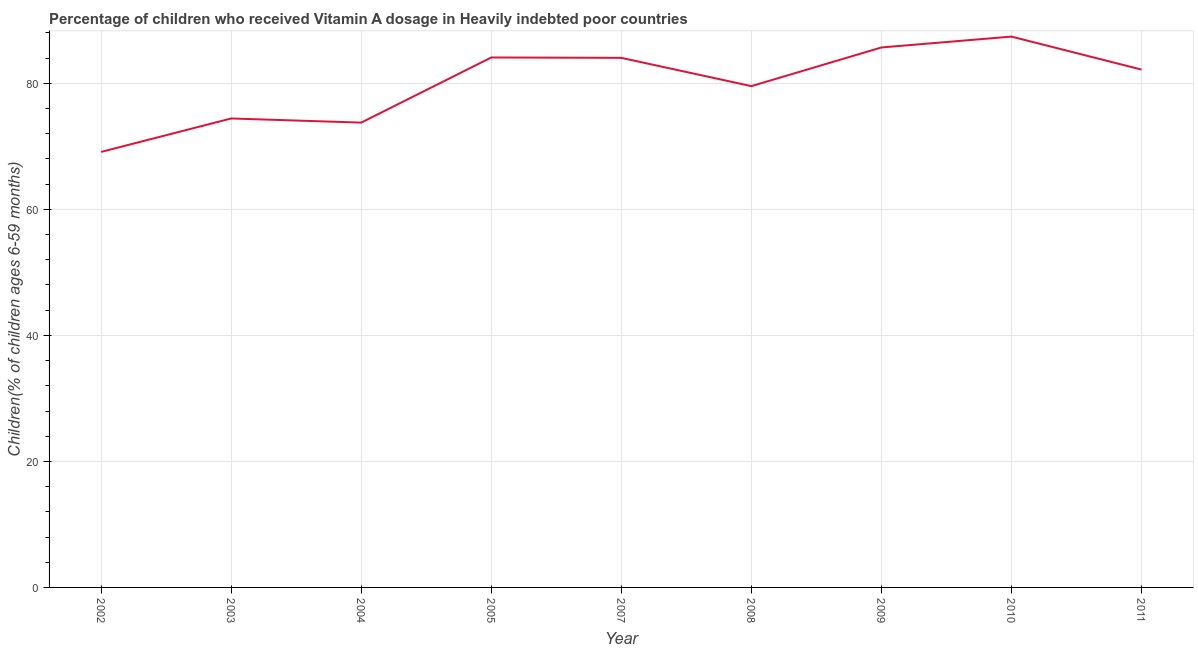What is the vitamin a supplementation coverage rate in 2009?
Make the answer very short. 85.7. Across all years, what is the maximum vitamin a supplementation coverage rate?
Your answer should be compact. 87.42. Across all years, what is the minimum vitamin a supplementation coverage rate?
Make the answer very short. 69.12. In which year was the vitamin a supplementation coverage rate minimum?
Offer a terse response. 2002. What is the sum of the vitamin a supplementation coverage rate?
Give a very brief answer. 720.35. What is the difference between the vitamin a supplementation coverage rate in 2002 and 2003?
Make the answer very short. -5.3. What is the average vitamin a supplementation coverage rate per year?
Provide a succinct answer. 80.04. What is the median vitamin a supplementation coverage rate?
Make the answer very short. 82.19. What is the ratio of the vitamin a supplementation coverage rate in 2007 to that in 2008?
Offer a terse response. 1.06. Is the vitamin a supplementation coverage rate in 2009 less than that in 2010?
Your response must be concise. Yes. What is the difference between the highest and the second highest vitamin a supplementation coverage rate?
Give a very brief answer. 1.72. What is the difference between the highest and the lowest vitamin a supplementation coverage rate?
Provide a succinct answer. 18.3. In how many years, is the vitamin a supplementation coverage rate greater than the average vitamin a supplementation coverage rate taken over all years?
Your answer should be compact. 5. Does the vitamin a supplementation coverage rate monotonically increase over the years?
Keep it short and to the point. No. How many lines are there?
Your answer should be very brief. 1. How many years are there in the graph?
Your answer should be very brief. 9. Are the values on the major ticks of Y-axis written in scientific E-notation?
Provide a succinct answer. No. Does the graph contain any zero values?
Offer a terse response. No. What is the title of the graph?
Provide a succinct answer. Percentage of children who received Vitamin A dosage in Heavily indebted poor countries. What is the label or title of the Y-axis?
Your answer should be very brief. Children(% of children ages 6-59 months). What is the Children(% of children ages 6-59 months) in 2002?
Provide a succinct answer. 69.12. What is the Children(% of children ages 6-59 months) in 2003?
Provide a short and direct response. 74.43. What is the Children(% of children ages 6-59 months) in 2004?
Make the answer very short. 73.77. What is the Children(% of children ages 6-59 months) in 2005?
Give a very brief answer. 84.11. What is the Children(% of children ages 6-59 months) in 2007?
Give a very brief answer. 84.05. What is the Children(% of children ages 6-59 months) in 2008?
Give a very brief answer. 79.56. What is the Children(% of children ages 6-59 months) in 2009?
Ensure brevity in your answer.  85.7. What is the Children(% of children ages 6-59 months) of 2010?
Your answer should be compact. 87.42. What is the Children(% of children ages 6-59 months) in 2011?
Ensure brevity in your answer.  82.19. What is the difference between the Children(% of children ages 6-59 months) in 2002 and 2003?
Your answer should be compact. -5.3. What is the difference between the Children(% of children ages 6-59 months) in 2002 and 2004?
Offer a very short reply. -4.65. What is the difference between the Children(% of children ages 6-59 months) in 2002 and 2005?
Make the answer very short. -14.99. What is the difference between the Children(% of children ages 6-59 months) in 2002 and 2007?
Provide a short and direct response. -14.93. What is the difference between the Children(% of children ages 6-59 months) in 2002 and 2008?
Make the answer very short. -10.44. What is the difference between the Children(% of children ages 6-59 months) in 2002 and 2009?
Your answer should be very brief. -16.58. What is the difference between the Children(% of children ages 6-59 months) in 2002 and 2010?
Ensure brevity in your answer.  -18.3. What is the difference between the Children(% of children ages 6-59 months) in 2002 and 2011?
Make the answer very short. -13.07. What is the difference between the Children(% of children ages 6-59 months) in 2003 and 2004?
Your answer should be compact. 0.66. What is the difference between the Children(% of children ages 6-59 months) in 2003 and 2005?
Make the answer very short. -9.68. What is the difference between the Children(% of children ages 6-59 months) in 2003 and 2007?
Make the answer very short. -9.62. What is the difference between the Children(% of children ages 6-59 months) in 2003 and 2008?
Provide a short and direct response. -5.13. What is the difference between the Children(% of children ages 6-59 months) in 2003 and 2009?
Offer a terse response. -11.27. What is the difference between the Children(% of children ages 6-59 months) in 2003 and 2010?
Ensure brevity in your answer.  -13. What is the difference between the Children(% of children ages 6-59 months) in 2003 and 2011?
Make the answer very short. -7.76. What is the difference between the Children(% of children ages 6-59 months) in 2004 and 2005?
Offer a terse response. -10.34. What is the difference between the Children(% of children ages 6-59 months) in 2004 and 2007?
Provide a succinct answer. -10.28. What is the difference between the Children(% of children ages 6-59 months) in 2004 and 2008?
Give a very brief answer. -5.79. What is the difference between the Children(% of children ages 6-59 months) in 2004 and 2009?
Keep it short and to the point. -11.93. What is the difference between the Children(% of children ages 6-59 months) in 2004 and 2010?
Your answer should be very brief. -13.65. What is the difference between the Children(% of children ages 6-59 months) in 2004 and 2011?
Your answer should be very brief. -8.42. What is the difference between the Children(% of children ages 6-59 months) in 2005 and 2007?
Keep it short and to the point. 0.06. What is the difference between the Children(% of children ages 6-59 months) in 2005 and 2008?
Give a very brief answer. 4.55. What is the difference between the Children(% of children ages 6-59 months) in 2005 and 2009?
Give a very brief answer. -1.59. What is the difference between the Children(% of children ages 6-59 months) in 2005 and 2010?
Give a very brief answer. -3.31. What is the difference between the Children(% of children ages 6-59 months) in 2005 and 2011?
Ensure brevity in your answer.  1.92. What is the difference between the Children(% of children ages 6-59 months) in 2007 and 2008?
Your response must be concise. 4.49. What is the difference between the Children(% of children ages 6-59 months) in 2007 and 2009?
Give a very brief answer. -1.65. What is the difference between the Children(% of children ages 6-59 months) in 2007 and 2010?
Give a very brief answer. -3.37. What is the difference between the Children(% of children ages 6-59 months) in 2007 and 2011?
Ensure brevity in your answer.  1.86. What is the difference between the Children(% of children ages 6-59 months) in 2008 and 2009?
Offer a terse response. -6.14. What is the difference between the Children(% of children ages 6-59 months) in 2008 and 2010?
Offer a very short reply. -7.86. What is the difference between the Children(% of children ages 6-59 months) in 2008 and 2011?
Keep it short and to the point. -2.63. What is the difference between the Children(% of children ages 6-59 months) in 2009 and 2010?
Your response must be concise. -1.72. What is the difference between the Children(% of children ages 6-59 months) in 2009 and 2011?
Your answer should be compact. 3.51. What is the difference between the Children(% of children ages 6-59 months) in 2010 and 2011?
Your response must be concise. 5.23. What is the ratio of the Children(% of children ages 6-59 months) in 2002 to that in 2003?
Keep it short and to the point. 0.93. What is the ratio of the Children(% of children ages 6-59 months) in 2002 to that in 2004?
Provide a succinct answer. 0.94. What is the ratio of the Children(% of children ages 6-59 months) in 2002 to that in 2005?
Keep it short and to the point. 0.82. What is the ratio of the Children(% of children ages 6-59 months) in 2002 to that in 2007?
Provide a succinct answer. 0.82. What is the ratio of the Children(% of children ages 6-59 months) in 2002 to that in 2008?
Provide a succinct answer. 0.87. What is the ratio of the Children(% of children ages 6-59 months) in 2002 to that in 2009?
Ensure brevity in your answer.  0.81. What is the ratio of the Children(% of children ages 6-59 months) in 2002 to that in 2010?
Ensure brevity in your answer.  0.79. What is the ratio of the Children(% of children ages 6-59 months) in 2002 to that in 2011?
Keep it short and to the point. 0.84. What is the ratio of the Children(% of children ages 6-59 months) in 2003 to that in 2004?
Make the answer very short. 1.01. What is the ratio of the Children(% of children ages 6-59 months) in 2003 to that in 2005?
Give a very brief answer. 0.89. What is the ratio of the Children(% of children ages 6-59 months) in 2003 to that in 2007?
Give a very brief answer. 0.89. What is the ratio of the Children(% of children ages 6-59 months) in 2003 to that in 2008?
Ensure brevity in your answer.  0.94. What is the ratio of the Children(% of children ages 6-59 months) in 2003 to that in 2009?
Offer a terse response. 0.87. What is the ratio of the Children(% of children ages 6-59 months) in 2003 to that in 2010?
Offer a very short reply. 0.85. What is the ratio of the Children(% of children ages 6-59 months) in 2003 to that in 2011?
Give a very brief answer. 0.91. What is the ratio of the Children(% of children ages 6-59 months) in 2004 to that in 2005?
Offer a very short reply. 0.88. What is the ratio of the Children(% of children ages 6-59 months) in 2004 to that in 2007?
Make the answer very short. 0.88. What is the ratio of the Children(% of children ages 6-59 months) in 2004 to that in 2008?
Ensure brevity in your answer.  0.93. What is the ratio of the Children(% of children ages 6-59 months) in 2004 to that in 2009?
Provide a succinct answer. 0.86. What is the ratio of the Children(% of children ages 6-59 months) in 2004 to that in 2010?
Provide a succinct answer. 0.84. What is the ratio of the Children(% of children ages 6-59 months) in 2004 to that in 2011?
Give a very brief answer. 0.9. What is the ratio of the Children(% of children ages 6-59 months) in 2005 to that in 2008?
Your response must be concise. 1.06. What is the ratio of the Children(% of children ages 6-59 months) in 2005 to that in 2009?
Provide a succinct answer. 0.98. What is the ratio of the Children(% of children ages 6-59 months) in 2005 to that in 2011?
Provide a short and direct response. 1.02. What is the ratio of the Children(% of children ages 6-59 months) in 2007 to that in 2008?
Keep it short and to the point. 1.06. What is the ratio of the Children(% of children ages 6-59 months) in 2007 to that in 2009?
Your response must be concise. 0.98. What is the ratio of the Children(% of children ages 6-59 months) in 2007 to that in 2011?
Give a very brief answer. 1.02. What is the ratio of the Children(% of children ages 6-59 months) in 2008 to that in 2009?
Offer a terse response. 0.93. What is the ratio of the Children(% of children ages 6-59 months) in 2008 to that in 2010?
Your answer should be very brief. 0.91. What is the ratio of the Children(% of children ages 6-59 months) in 2008 to that in 2011?
Provide a short and direct response. 0.97. What is the ratio of the Children(% of children ages 6-59 months) in 2009 to that in 2011?
Give a very brief answer. 1.04. What is the ratio of the Children(% of children ages 6-59 months) in 2010 to that in 2011?
Offer a very short reply. 1.06. 